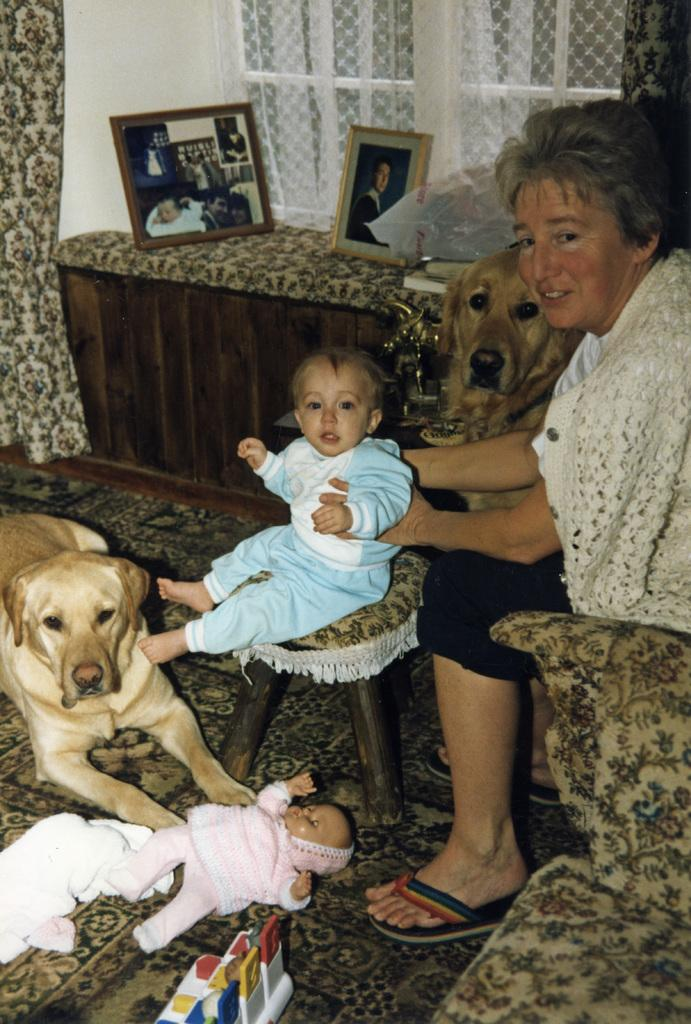What color is the wall in the image? The wall in the image is white. What can be seen hanging near the window? There is a curtain hanging near the window. What is present in the background of the image? There is a window, a photo frame, and a table in the background of the image. What type of furniture is the woman sitting on? The woman is sitting on a sofa. What is the child doing in the image? The child is sitting on a stool. What other living creature is present in the image? There is a dog in the image. What other object is present in the image? There is a doll in the image. What type of farm animals can be seen in the image? There are no farm animals present in the image. What type of art is displayed in the photo frame in the image? The content of the photo frame is not visible in the image, so it cannot be determined if any art is displayed. 